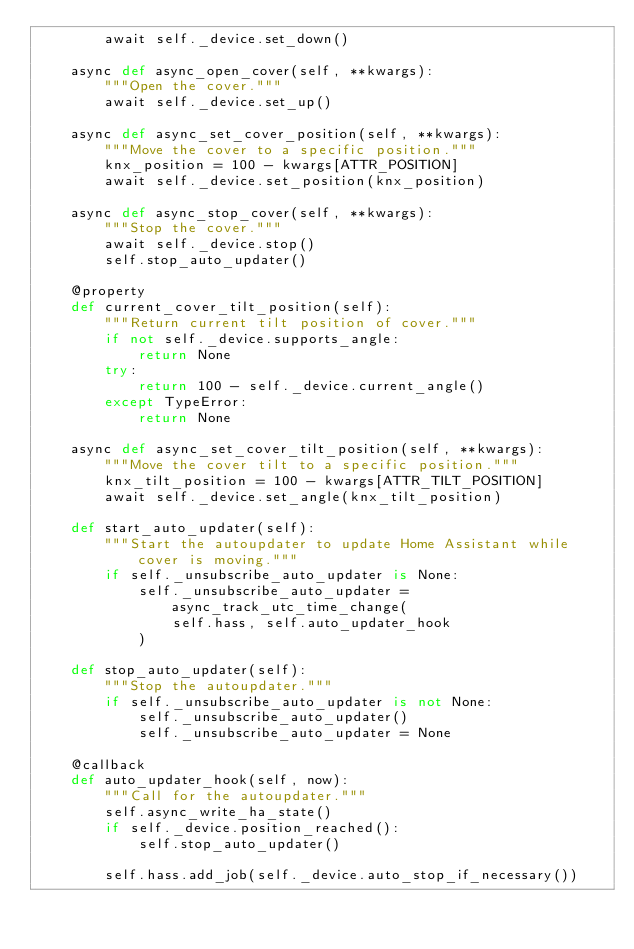Convert code to text. <code><loc_0><loc_0><loc_500><loc_500><_Python_>        await self._device.set_down()

    async def async_open_cover(self, **kwargs):
        """Open the cover."""
        await self._device.set_up()

    async def async_set_cover_position(self, **kwargs):
        """Move the cover to a specific position."""
        knx_position = 100 - kwargs[ATTR_POSITION]
        await self._device.set_position(knx_position)

    async def async_stop_cover(self, **kwargs):
        """Stop the cover."""
        await self._device.stop()
        self.stop_auto_updater()

    @property
    def current_cover_tilt_position(self):
        """Return current tilt position of cover."""
        if not self._device.supports_angle:
            return None
        try:
            return 100 - self._device.current_angle()
        except TypeError:
            return None

    async def async_set_cover_tilt_position(self, **kwargs):
        """Move the cover tilt to a specific position."""
        knx_tilt_position = 100 - kwargs[ATTR_TILT_POSITION]
        await self._device.set_angle(knx_tilt_position)

    def start_auto_updater(self):
        """Start the autoupdater to update Home Assistant while cover is moving."""
        if self._unsubscribe_auto_updater is None:
            self._unsubscribe_auto_updater = async_track_utc_time_change(
                self.hass, self.auto_updater_hook
            )

    def stop_auto_updater(self):
        """Stop the autoupdater."""
        if self._unsubscribe_auto_updater is not None:
            self._unsubscribe_auto_updater()
            self._unsubscribe_auto_updater = None

    @callback
    def auto_updater_hook(self, now):
        """Call for the autoupdater."""
        self.async_write_ha_state()
        if self._device.position_reached():
            self.stop_auto_updater()

        self.hass.add_job(self._device.auto_stop_if_necessary())
</code> 